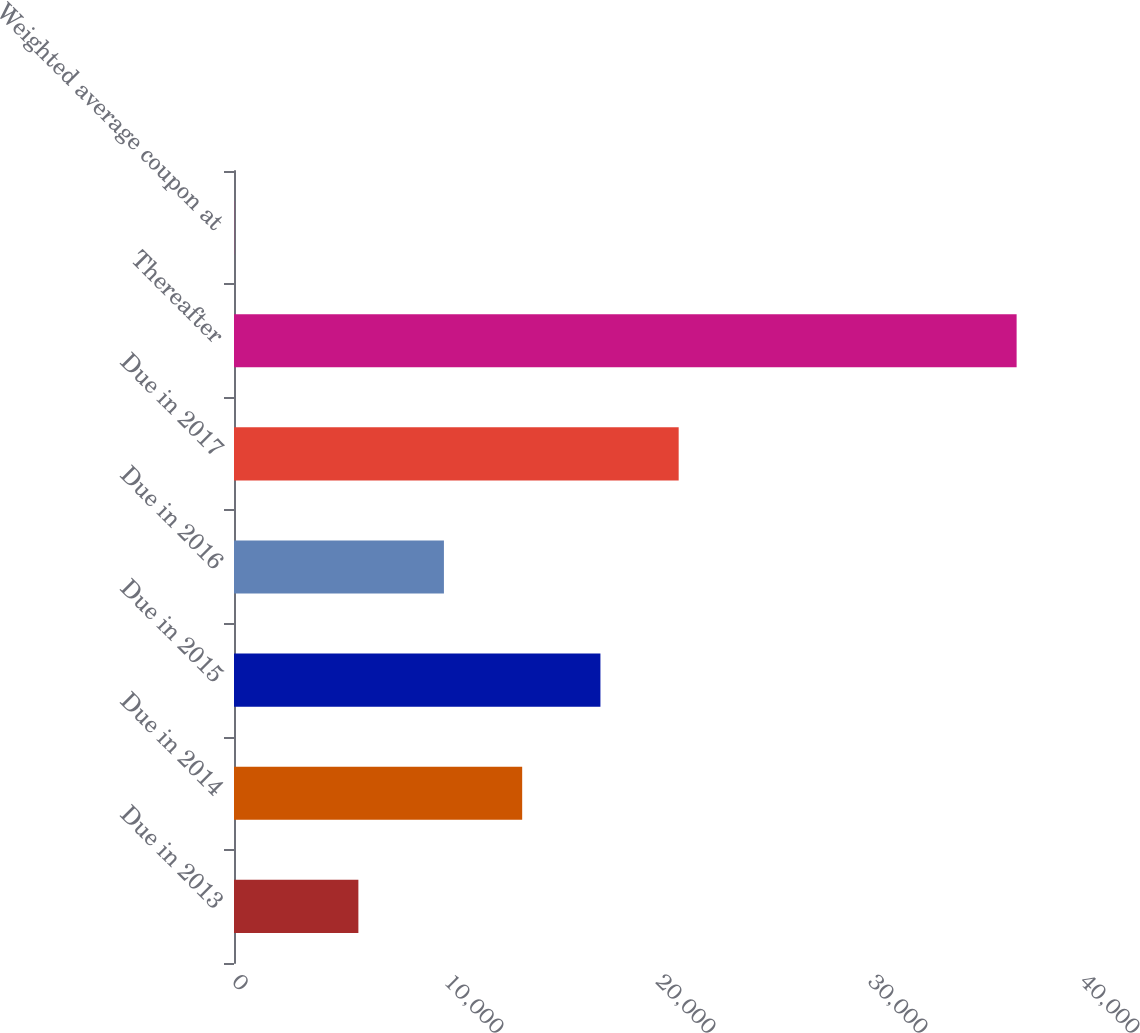<chart> <loc_0><loc_0><loc_500><loc_500><bar_chart><fcel>Due in 2013<fcel>Due in 2014<fcel>Due in 2015<fcel>Due in 2016<fcel>Due in 2017<fcel>Thereafter<fcel>Weighted average coupon at<nl><fcel>5867<fcel>13593.1<fcel>17284.1<fcel>9902<fcel>20975.2<fcel>36916<fcel>5.3<nl></chart> 